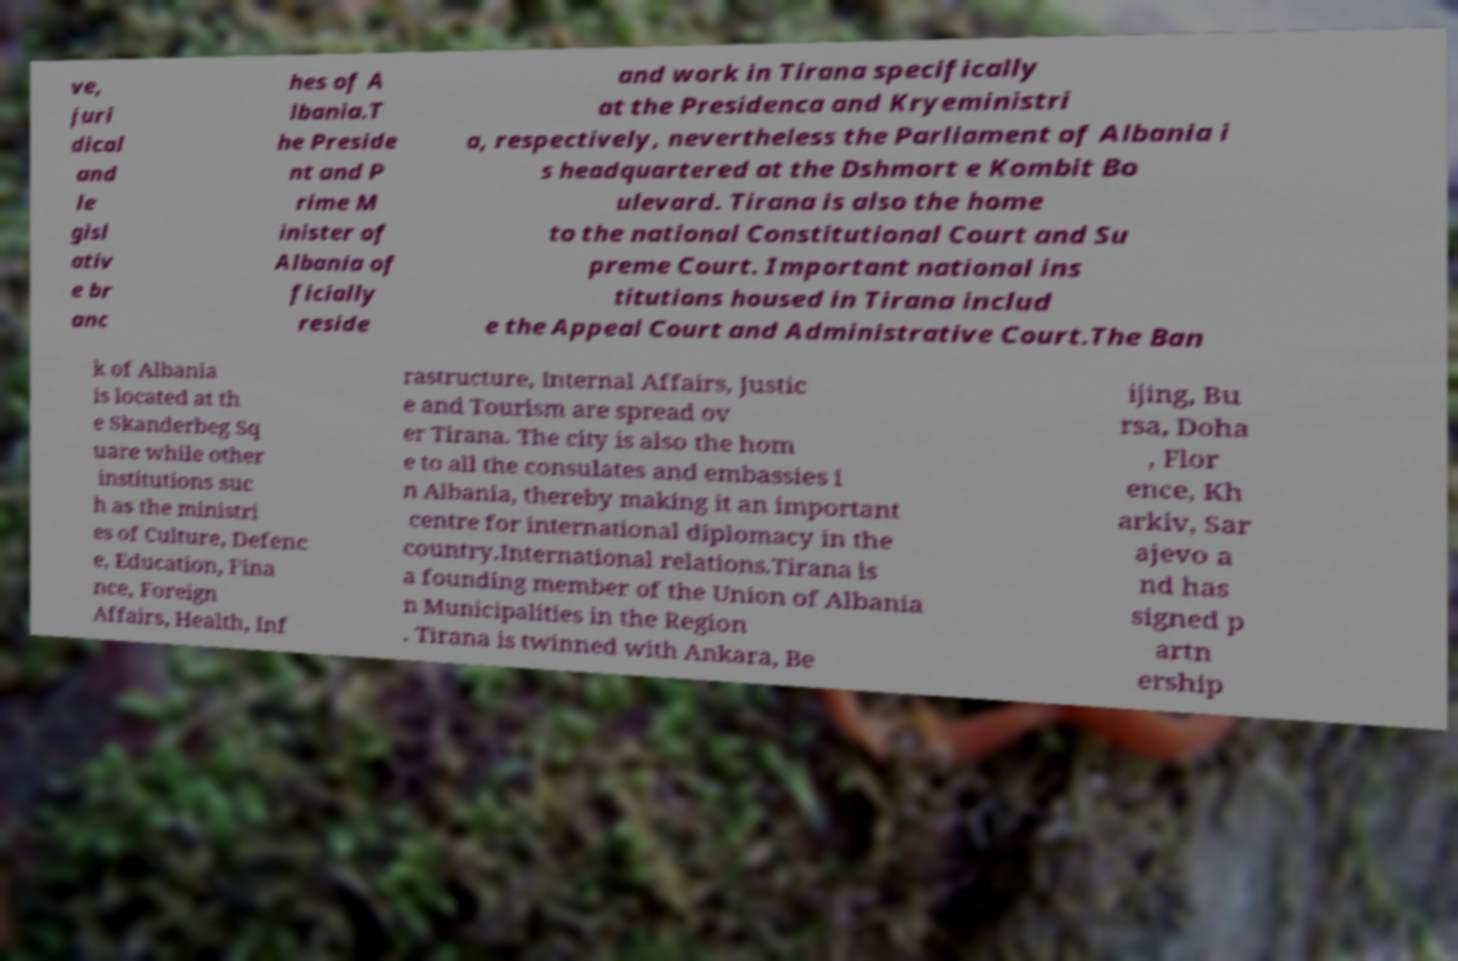For documentation purposes, I need the text within this image transcribed. Could you provide that? ve, juri dical and le gisl ativ e br anc hes of A lbania.T he Preside nt and P rime M inister of Albania of ficially reside and work in Tirana specifically at the Presidenca and Kryeministri a, respectively, nevertheless the Parliament of Albania i s headquartered at the Dshmort e Kombit Bo ulevard. Tirana is also the home to the national Constitutional Court and Su preme Court. Important national ins titutions housed in Tirana includ e the Appeal Court and Administrative Court.The Ban k of Albania is located at th e Skanderbeg Sq uare while other institutions suc h as the ministri es of Culture, Defenc e, Education, Fina nce, Foreign Affairs, Health, Inf rastructure, Internal Affairs, Justic e and Tourism are spread ov er Tirana. The city is also the hom e to all the consulates and embassies i n Albania, thereby making it an important centre for international diplomacy in the country.International relations.Tirana is a founding member of the Union of Albania n Municipalities in the Region . Tirana is twinned with Ankara, Be ijing, Bu rsa, Doha , Flor ence, Kh arkiv, Sar ajevo a nd has signed p artn ership 